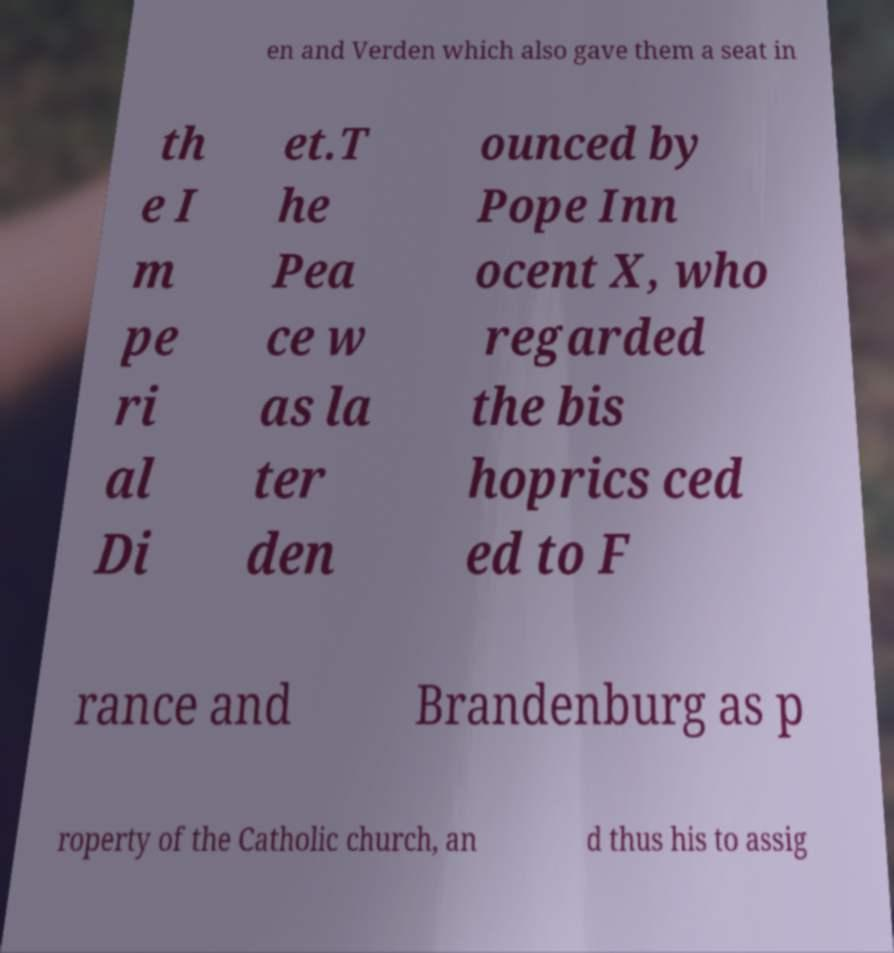Can you read and provide the text displayed in the image?This photo seems to have some interesting text. Can you extract and type it out for me? en and Verden which also gave them a seat in th e I m pe ri al Di et.T he Pea ce w as la ter den ounced by Pope Inn ocent X, who regarded the bis hoprics ced ed to F rance and Brandenburg as p roperty of the Catholic church, an d thus his to assig 